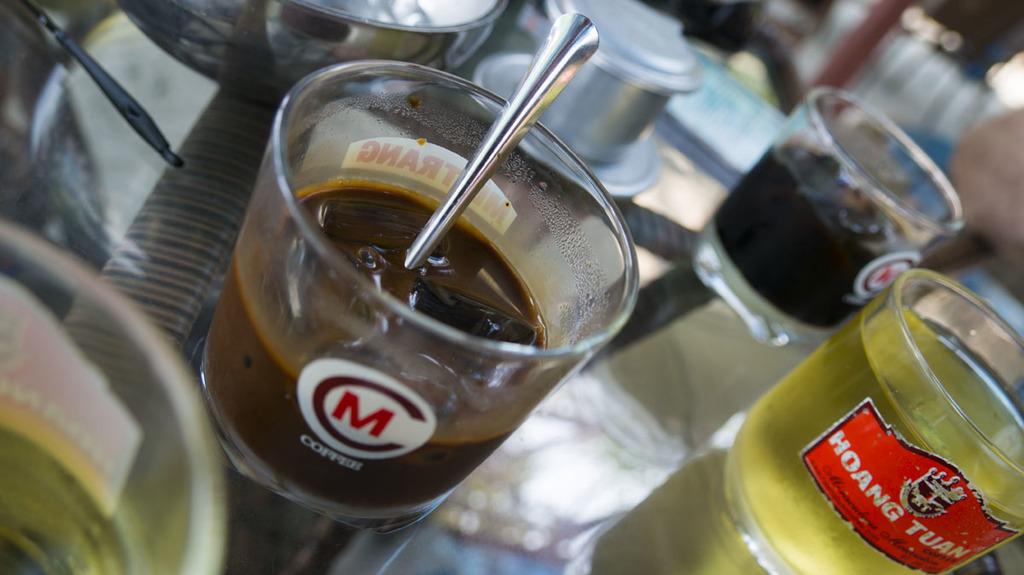What is the beverage on the left side?
Ensure brevity in your answer.  Coffee. 